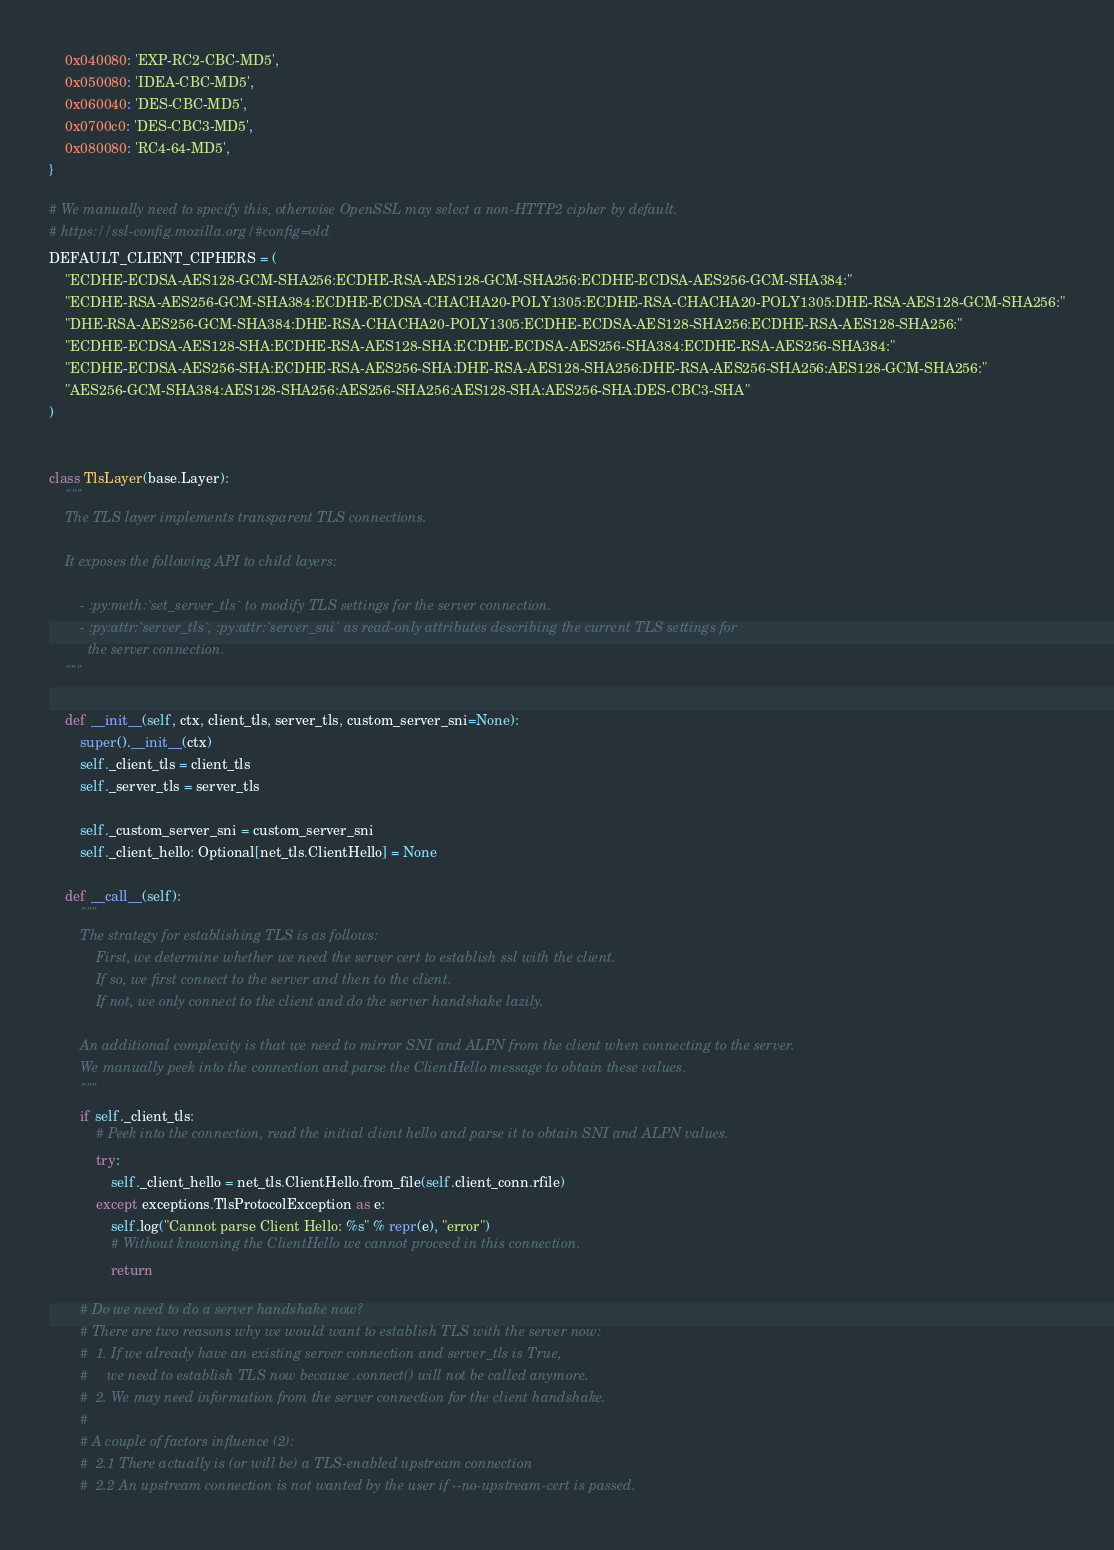Convert code to text. <code><loc_0><loc_0><loc_500><loc_500><_Python_>    0x040080: 'EXP-RC2-CBC-MD5',
    0x050080: 'IDEA-CBC-MD5',
    0x060040: 'DES-CBC-MD5',
    0x0700c0: 'DES-CBC3-MD5',
    0x080080: 'RC4-64-MD5',
}

# We manually need to specify this, otherwise OpenSSL may select a non-HTTP2 cipher by default.
# https://ssl-config.mozilla.org/#config=old
DEFAULT_CLIENT_CIPHERS = (
    "ECDHE-ECDSA-AES128-GCM-SHA256:ECDHE-RSA-AES128-GCM-SHA256:ECDHE-ECDSA-AES256-GCM-SHA384:"
    "ECDHE-RSA-AES256-GCM-SHA384:ECDHE-ECDSA-CHACHA20-POLY1305:ECDHE-RSA-CHACHA20-POLY1305:DHE-RSA-AES128-GCM-SHA256:"
    "DHE-RSA-AES256-GCM-SHA384:DHE-RSA-CHACHA20-POLY1305:ECDHE-ECDSA-AES128-SHA256:ECDHE-RSA-AES128-SHA256:"
    "ECDHE-ECDSA-AES128-SHA:ECDHE-RSA-AES128-SHA:ECDHE-ECDSA-AES256-SHA384:ECDHE-RSA-AES256-SHA384:"
    "ECDHE-ECDSA-AES256-SHA:ECDHE-RSA-AES256-SHA:DHE-RSA-AES128-SHA256:DHE-RSA-AES256-SHA256:AES128-GCM-SHA256:"
    "AES256-GCM-SHA384:AES128-SHA256:AES256-SHA256:AES128-SHA:AES256-SHA:DES-CBC3-SHA"
)


class TlsLayer(base.Layer):
    """
    The TLS layer implements transparent TLS connections.

    It exposes the following API to child layers:

        - :py:meth:`set_server_tls` to modify TLS settings for the server connection.
        - :py:attr:`server_tls`, :py:attr:`server_sni` as read-only attributes describing the current TLS settings for
          the server connection.
    """

    def __init__(self, ctx, client_tls, server_tls, custom_server_sni=None):
        super().__init__(ctx)
        self._client_tls = client_tls
        self._server_tls = server_tls

        self._custom_server_sni = custom_server_sni
        self._client_hello: Optional[net_tls.ClientHello] = None

    def __call__(self):
        """
        The strategy for establishing TLS is as follows:
            First, we determine whether we need the server cert to establish ssl with the client.
            If so, we first connect to the server and then to the client.
            If not, we only connect to the client and do the server handshake lazily.

        An additional complexity is that we need to mirror SNI and ALPN from the client when connecting to the server.
        We manually peek into the connection and parse the ClientHello message to obtain these values.
        """
        if self._client_tls:
            # Peek into the connection, read the initial client hello and parse it to obtain SNI and ALPN values.
            try:
                self._client_hello = net_tls.ClientHello.from_file(self.client_conn.rfile)
            except exceptions.TlsProtocolException as e:
                self.log("Cannot parse Client Hello: %s" % repr(e), "error")
                # Without knowning the ClientHello we cannot proceed in this connection.
                return

        # Do we need to do a server handshake now?
        # There are two reasons why we would want to establish TLS with the server now:
        #  1. If we already have an existing server connection and server_tls is True,
        #     we need to establish TLS now because .connect() will not be called anymore.
        #  2. We may need information from the server connection for the client handshake.
        #
        # A couple of factors influence (2):
        #  2.1 There actually is (or will be) a TLS-enabled upstream connection
        #  2.2 An upstream connection is not wanted by the user if --no-upstream-cert is passed.</code> 